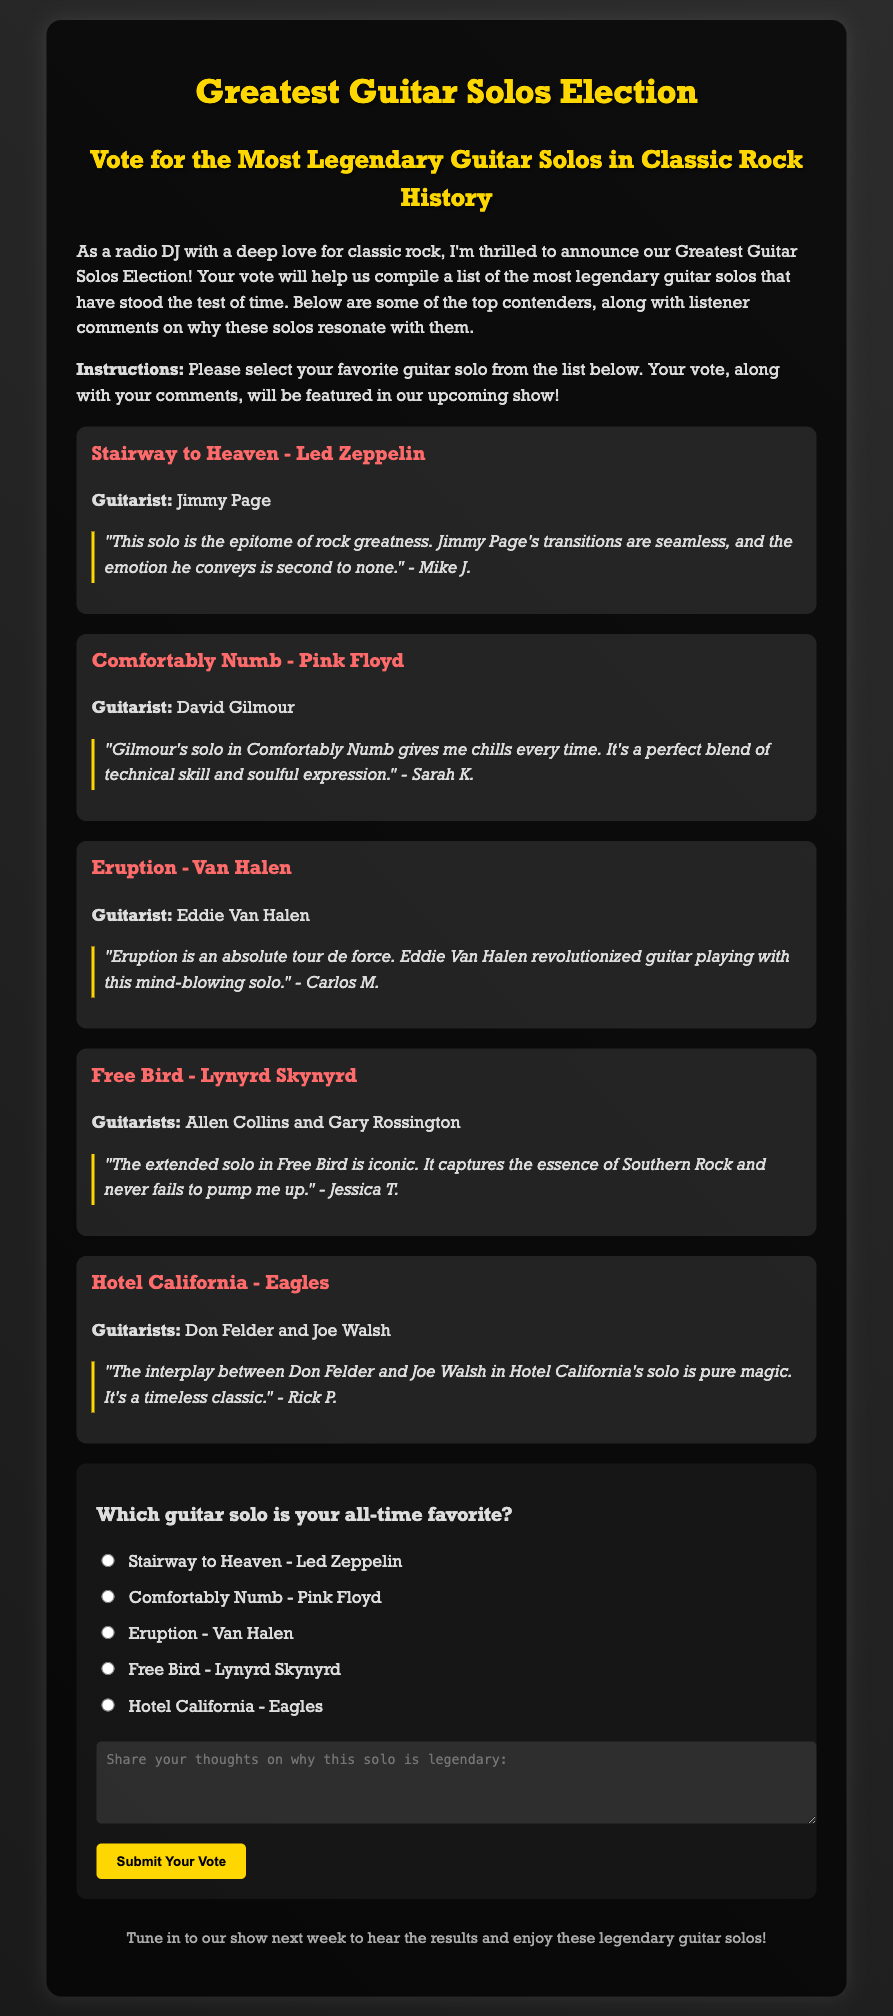What is the title of the election? The title of the election is stated at the top of the document.
Answer: Greatest Guitar Solos Election Who is the guitarist for "Comfortably Numb"? The guitarist for "Comfortably Numb" is mentioned in the section for this solo.
Answer: David Gilmour How many guitar solos are listed in the document? The document details five specific guitar solos in the election.
Answer: Five What comment did Mike J. leave about "Stairway to Heaven"? Mike J.'s comment is provided under the "Stairway to Heaven" solo section.
Answer: "This solo is the epitome of rock greatness. Jimmy Page's transitions are seamless, and the emotion he conveys is second to none." Which solo is described as a "tour de force"? The description of "Eruption" mentions it as an absolute tour de force.
Answer: Eruption What color is the background gradient of the document? The background gradient colors are specified in the document's styling section.
Answer: Dark gray What will listeners hear next week? The footer section indicates what listeners can expect in the next show.
Answer: The results and enjoy these legendary guitar solos What is the purpose of the form in the document? The form allows listeners to vote for their favorite guitar solo and share comments.
Answer: To submit votes and comments 